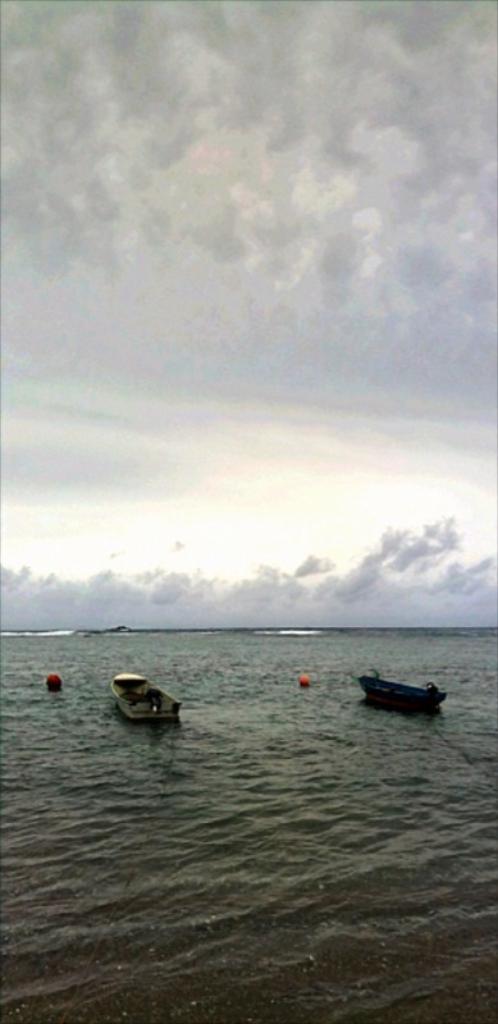In one or two sentences, can you explain what this image depicts? At the bottom of the image we can see boats on the river. In the background there is sky. 